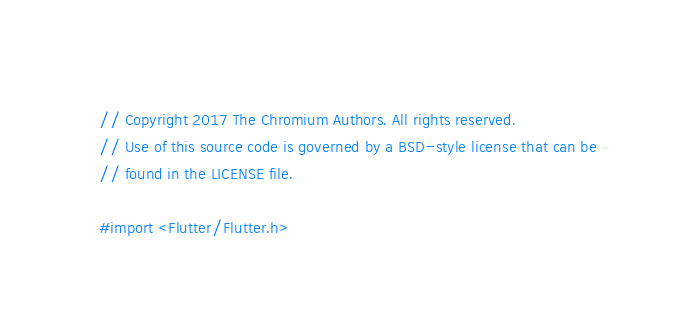Convert code to text. <code><loc_0><loc_0><loc_500><loc_500><_C_>// Copyright 2017 The Chromium Authors. All rights reserved.
// Use of this source code is governed by a BSD-style license that can be
// found in the LICENSE file.

#import <Flutter/Flutter.h>
</code> 